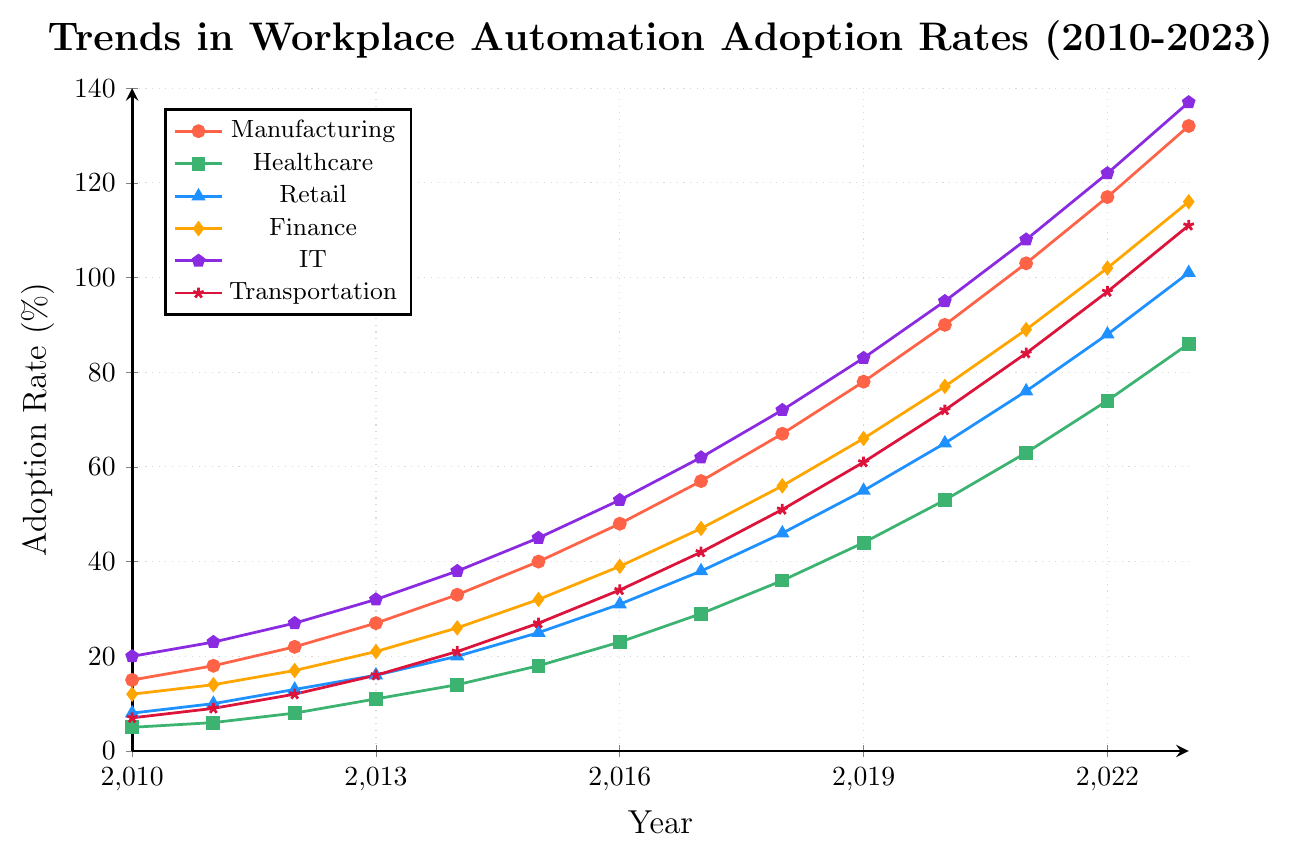Which sector had the highest automation adoption rate in 2013? By looking at the figure, observe the y-values corresponding to the year 2013 for each sector. The highest y-value is for Manufacturing.
Answer: Manufacturing How much did the adoption rate for IT increase from 2010 to 2023? Find the initial value in 2010 (20%) and the final value in 2023 (137%) for IT. Calculate the difference, which is 137% - 20% = 117%.
Answer: 117% What is the average automation adoption rate for the Healthcare sector from 2010 to 2023? Sum the adoption rates from 2010 to 2023 and divide by the number of years: (5 + 6 + 8 + 11 + 14 + 18 + 23 + 29 + 36 + 44 + 53 + 63 + 74 + 86) / 14 = 32.43%.
Answer: 32.43% Which two sectors had the closest adoption rates in 2020? By looking at the 2020 data points, compare the adoption rates: Manufacturing (90), Healthcare (53), Retail (65), Finance (77), IT (95), Transportation (72). The closest rates are Finance (77) and Transportation (72), with a difference of 5%.
Answer: Finance and Transportation Between 2016 and 2019, which sector had the largest proportional increase in automation adoption? Calculate the proportional increase for each sector:
- Manufacturing: (78 - 48) / 48 = 0.625
- Healthcare: (44 - 23) / 23 = 0.913
- Retail: (55 - 31) / 31 = 0.774
- Finance: (66 - 39) / 39 = 0.692
- IT: (83 - 53) / 53 = 0.566
- Transportation: (61 - 34) / 34 = 0.794.
The largest proportional increase is in Healthcare.
Answer: Healthcare Which sector showed a steady increase without any decline from 2010 to 2023? By analyzing each line, observe that all sectors show a steady increase, so they all meet the criteria.
Answer: All sectors What was the adoption rate difference between Finance and Retail sectors in 2012? Look at the adoption rates for Finance (17%) and Retail (13%) in 2012 and calculate the difference, which is 17% - 13% = 4%.
Answer: 4% From 2017 to 2020, did the growth rate in automation adoption for Manufacturing exceed that of Healthcare? Calculate the growth for both sectors:
- Manufacturing: (90 - 57) / 57 = 0.579
- Healthcare: (53 - 29) / 29 = 0.655.
Since 0.579 < 0.655, Healthcare's growth rate exceeded Manufacturing's.
Answer: No Which sector had the lowest rate of increase from 2011 to 2013? Calculate the rate of increase for each sector:
- Manufacturing: (27 - 18) / 18 ≈ 0.5
- Healthcare: (11 - 6) / 6 ≈ 0.833
- Retail: (16 - 10) / 10 = 0.6
- Finance: (21 - 14) / 14 ≈ 0.5
- IT: (32 - 23) / 23 ≈ 0.391
- Transportation: (16 - 9) / 9 ≈ 0.778.
The lowest rate of increase is in IT.
Answer: IT In 2023, how does the automation rate in Retail compare to the combined rate of Healthcare and Transportation? Check 2023 rates: Retail (101%), Healthcare (86%), Transportation (111%). Combined rate of Healthcare and Transportation is 86 + 111 = 197%. Retail (101%) is less than 197%.
Answer: Less 